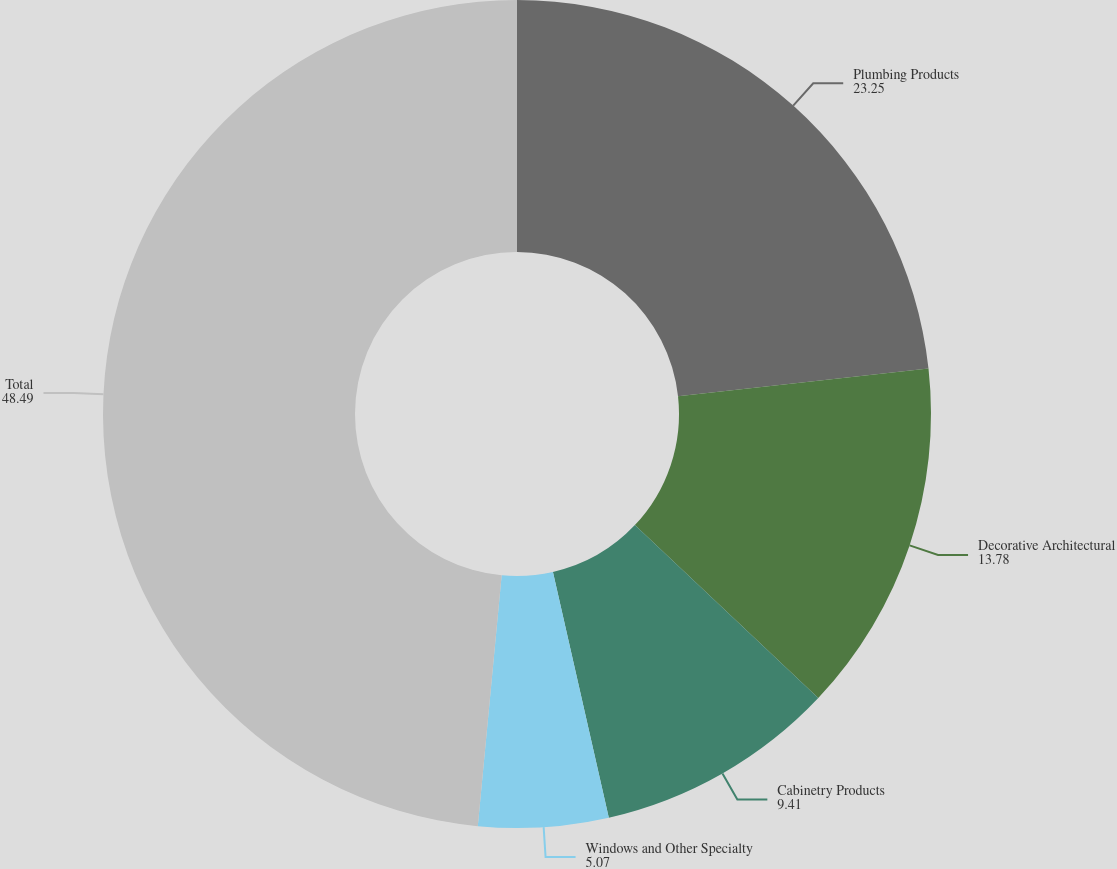Convert chart. <chart><loc_0><loc_0><loc_500><loc_500><pie_chart><fcel>Plumbing Products<fcel>Decorative Architectural<fcel>Cabinetry Products<fcel>Windows and Other Specialty<fcel>Total<nl><fcel>23.25%<fcel>13.78%<fcel>9.41%<fcel>5.07%<fcel>48.49%<nl></chart> 